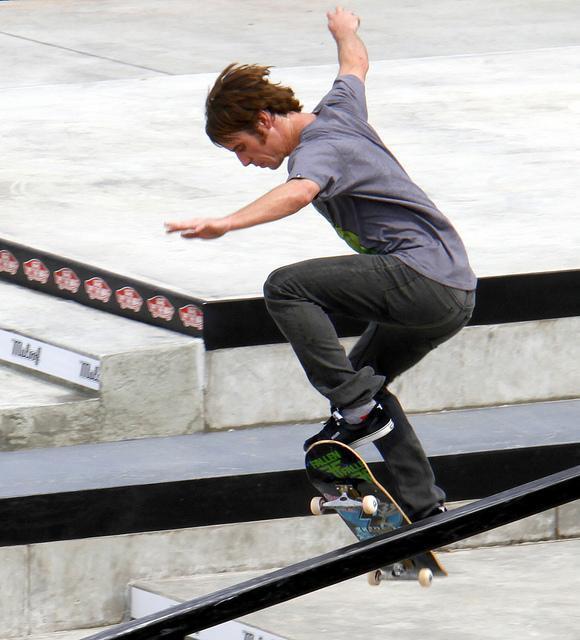How many clocks are visible?
Give a very brief answer. 0. 